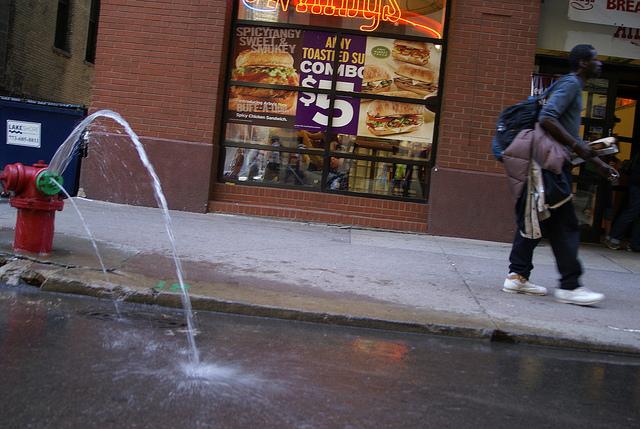What Mexican restaurant is present?
Give a very brief answer. None. What color is the man's suitcase?
Be succinct. Blue. What is the dollar amount on the sign in the window?
Keep it brief. 5. Is the man with the backpack hiking?
Short answer required. No. How many people are there?
Answer briefly. 1. What are the people doing?
Short answer required. Walking. What is the person holding?
Keep it brief. Book. What is the man doing?
Short answer required. Walking. Is there any trash on the ground?
Keep it brief. No. Is this in front of a fast food place?
Give a very brief answer. Yes. 